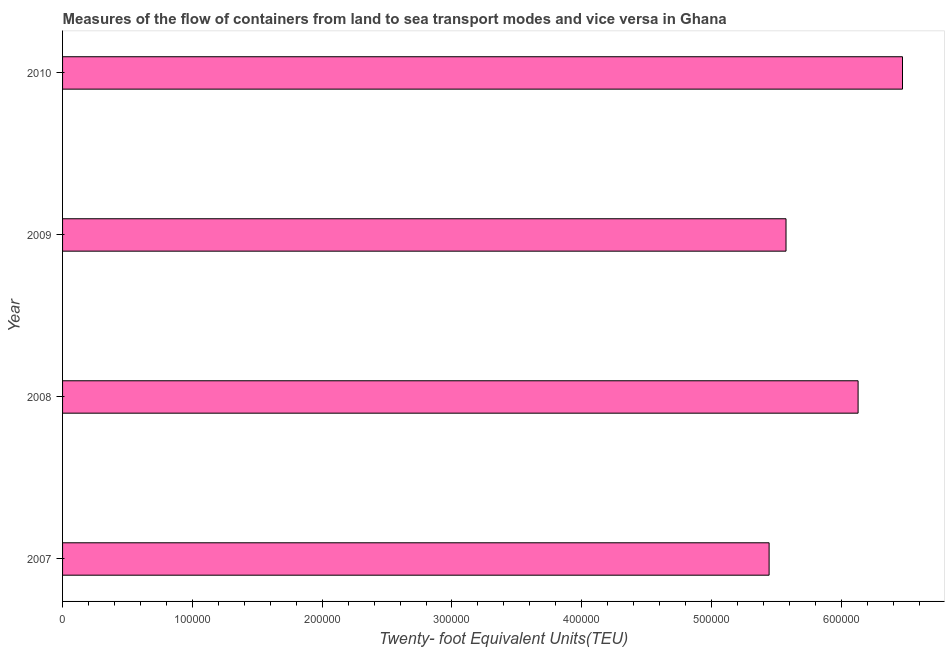Does the graph contain any zero values?
Your answer should be compact. No. Does the graph contain grids?
Offer a very short reply. No. What is the title of the graph?
Make the answer very short. Measures of the flow of containers from land to sea transport modes and vice versa in Ghana. What is the label or title of the X-axis?
Ensure brevity in your answer.  Twenty- foot Equivalent Units(TEU). What is the container port traffic in 2007?
Make the answer very short. 5.44e+05. Across all years, what is the maximum container port traffic?
Your answer should be compact. 6.47e+05. Across all years, what is the minimum container port traffic?
Your answer should be very brief. 5.44e+05. In which year was the container port traffic minimum?
Your response must be concise. 2007. What is the sum of the container port traffic?
Offer a terse response. 2.36e+06. What is the difference between the container port traffic in 2008 and 2009?
Provide a short and direct response. 5.55e+04. What is the average container port traffic per year?
Give a very brief answer. 5.90e+05. What is the median container port traffic?
Give a very brief answer. 5.85e+05. In how many years, is the container port traffic greater than 380000 TEU?
Your answer should be compact. 4. What is the ratio of the container port traffic in 2007 to that in 2009?
Make the answer very short. 0.98. What is the difference between the highest and the second highest container port traffic?
Keep it short and to the point. 3.42e+04. Is the sum of the container port traffic in 2007 and 2010 greater than the maximum container port traffic across all years?
Provide a short and direct response. Yes. What is the difference between the highest and the lowest container port traffic?
Give a very brief answer. 1.03e+05. In how many years, is the container port traffic greater than the average container port traffic taken over all years?
Make the answer very short. 2. How many bars are there?
Your response must be concise. 4. Are all the bars in the graph horizontal?
Your answer should be very brief. Yes. How many years are there in the graph?
Give a very brief answer. 4. Are the values on the major ticks of X-axis written in scientific E-notation?
Give a very brief answer. No. What is the Twenty- foot Equivalent Units(TEU) in 2007?
Provide a succinct answer. 5.44e+05. What is the Twenty- foot Equivalent Units(TEU) in 2008?
Offer a terse response. 6.13e+05. What is the Twenty- foot Equivalent Units(TEU) of 2009?
Your answer should be compact. 5.57e+05. What is the Twenty- foot Equivalent Units(TEU) in 2010?
Offer a terse response. 6.47e+05. What is the difference between the Twenty- foot Equivalent Units(TEU) in 2007 and 2008?
Offer a very short reply. -6.86e+04. What is the difference between the Twenty- foot Equivalent Units(TEU) in 2007 and 2009?
Keep it short and to the point. -1.30e+04. What is the difference between the Twenty- foot Equivalent Units(TEU) in 2007 and 2010?
Provide a succinct answer. -1.03e+05. What is the difference between the Twenty- foot Equivalent Units(TEU) in 2008 and 2009?
Offer a very short reply. 5.55e+04. What is the difference between the Twenty- foot Equivalent Units(TEU) in 2008 and 2010?
Your answer should be compact. -3.42e+04. What is the difference between the Twenty- foot Equivalent Units(TEU) in 2009 and 2010?
Your answer should be very brief. -8.97e+04. What is the ratio of the Twenty- foot Equivalent Units(TEU) in 2007 to that in 2008?
Provide a succinct answer. 0.89. What is the ratio of the Twenty- foot Equivalent Units(TEU) in 2007 to that in 2009?
Provide a succinct answer. 0.98. What is the ratio of the Twenty- foot Equivalent Units(TEU) in 2007 to that in 2010?
Ensure brevity in your answer.  0.84. What is the ratio of the Twenty- foot Equivalent Units(TEU) in 2008 to that in 2009?
Keep it short and to the point. 1.1. What is the ratio of the Twenty- foot Equivalent Units(TEU) in 2008 to that in 2010?
Provide a short and direct response. 0.95. What is the ratio of the Twenty- foot Equivalent Units(TEU) in 2009 to that in 2010?
Ensure brevity in your answer.  0.86. 